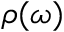Convert formula to latex. <formula><loc_0><loc_0><loc_500><loc_500>\rho ( \omega )</formula> 